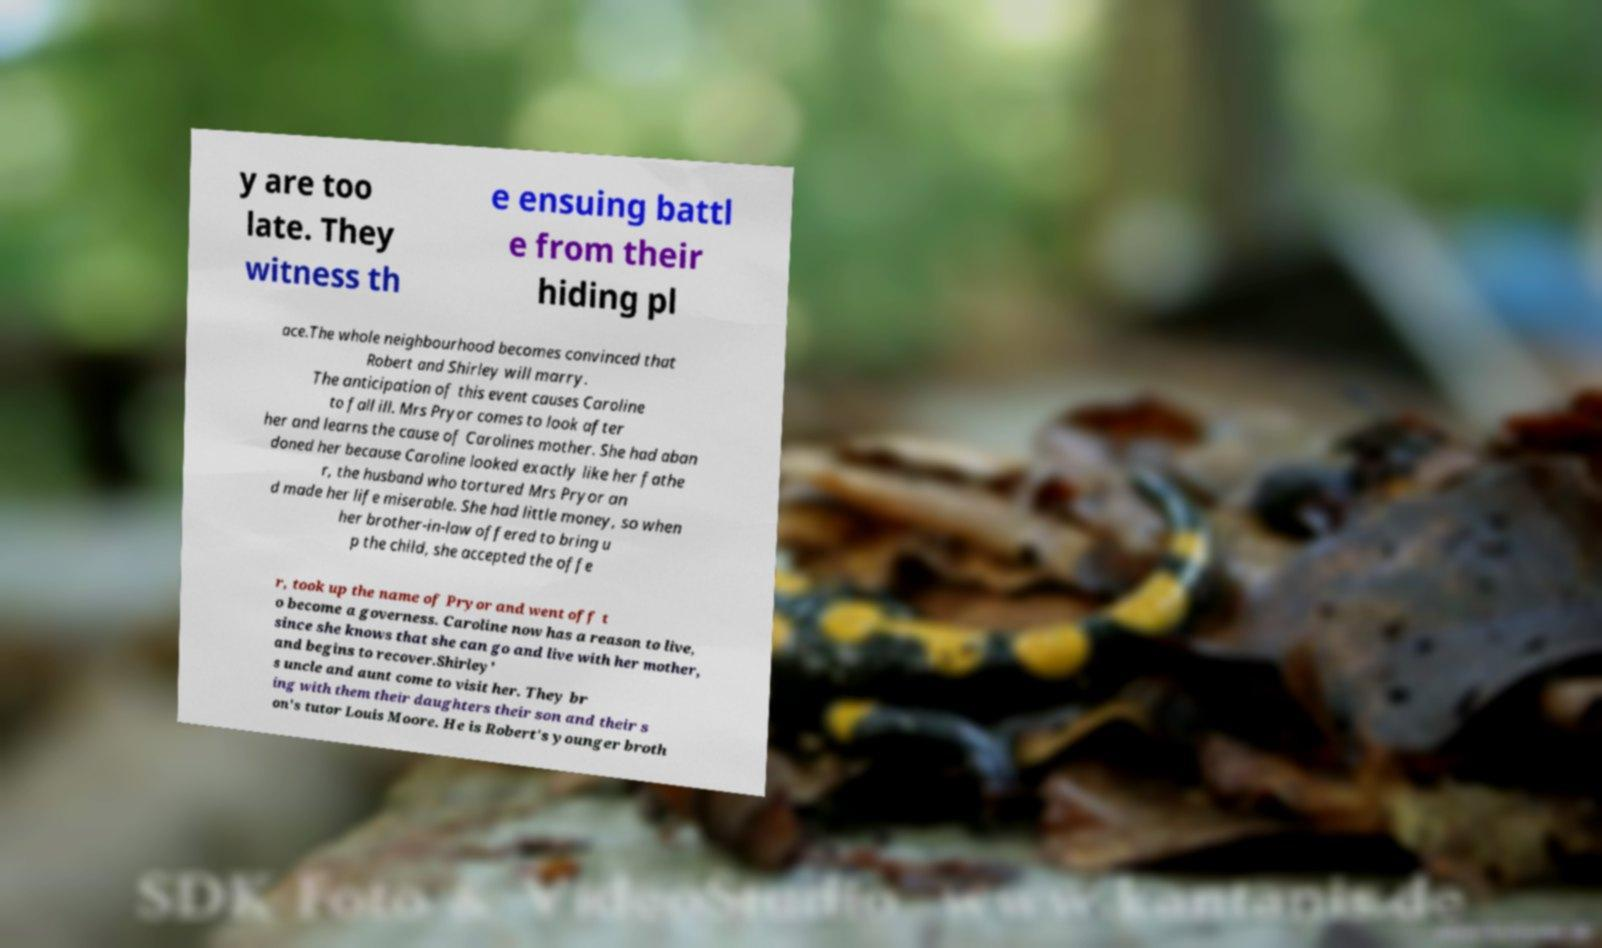Please identify and transcribe the text found in this image. y are too late. They witness th e ensuing battl e from their hiding pl ace.The whole neighbourhood becomes convinced that Robert and Shirley will marry. The anticipation of this event causes Caroline to fall ill. Mrs Pryor comes to look after her and learns the cause of Carolines mother. She had aban doned her because Caroline looked exactly like her fathe r, the husband who tortured Mrs Pryor an d made her life miserable. She had little money, so when her brother-in-law offered to bring u p the child, she accepted the offe r, took up the name of Pryor and went off t o become a governess. Caroline now has a reason to live, since she knows that she can go and live with her mother, and begins to recover.Shirley' s uncle and aunt come to visit her. They br ing with them their daughters their son and their s on's tutor Louis Moore. He is Robert's younger broth 